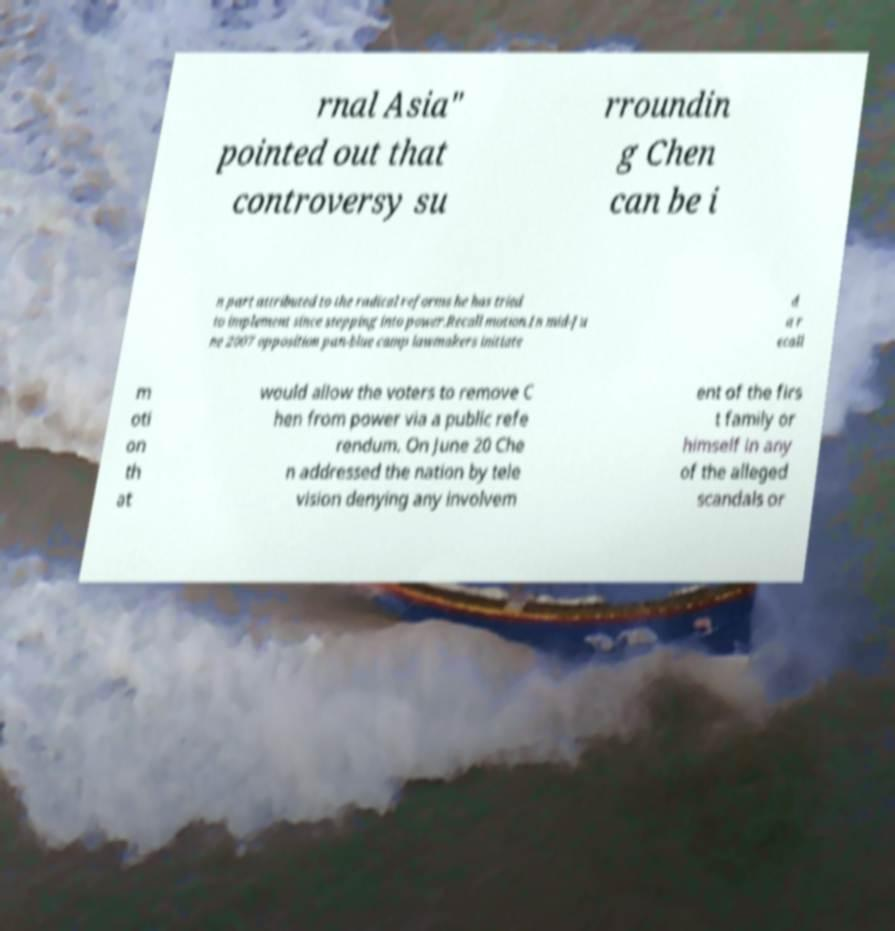I need the written content from this picture converted into text. Can you do that? rnal Asia" pointed out that controversy su rroundin g Chen can be i n part attributed to the radical reforms he has tried to implement since stepping into power.Recall motion.In mid-Ju ne 2007 opposition pan-blue camp lawmakers initiate d a r ecall m oti on th at would allow the voters to remove C hen from power via a public refe rendum. On June 20 Che n addressed the nation by tele vision denying any involvem ent of the firs t family or himself in any of the alleged scandals or 